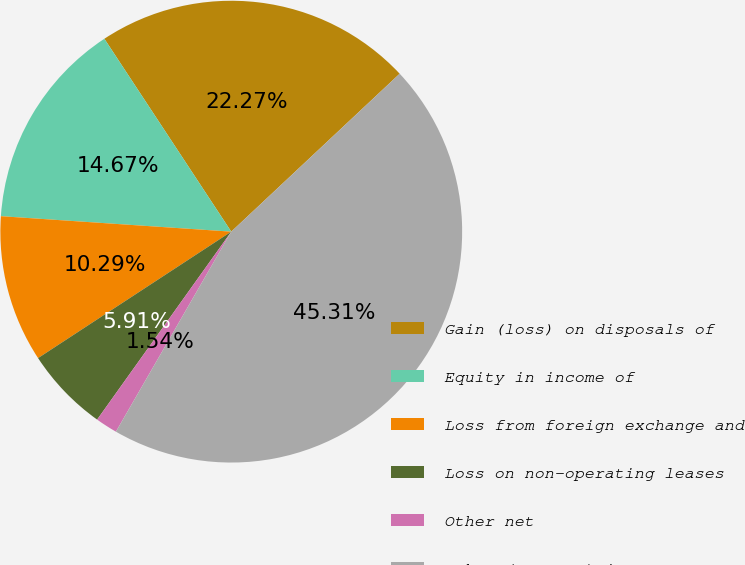Convert chart to OTSL. <chart><loc_0><loc_0><loc_500><loc_500><pie_chart><fcel>Gain (loss) on disposals of<fcel>Equity in income of<fcel>Loss from foreign exchange and<fcel>Loss on non-operating leases<fcel>Other net<fcel>Other (expense) income net<nl><fcel>22.27%<fcel>14.67%<fcel>10.29%<fcel>5.91%<fcel>1.54%<fcel>45.31%<nl></chart> 